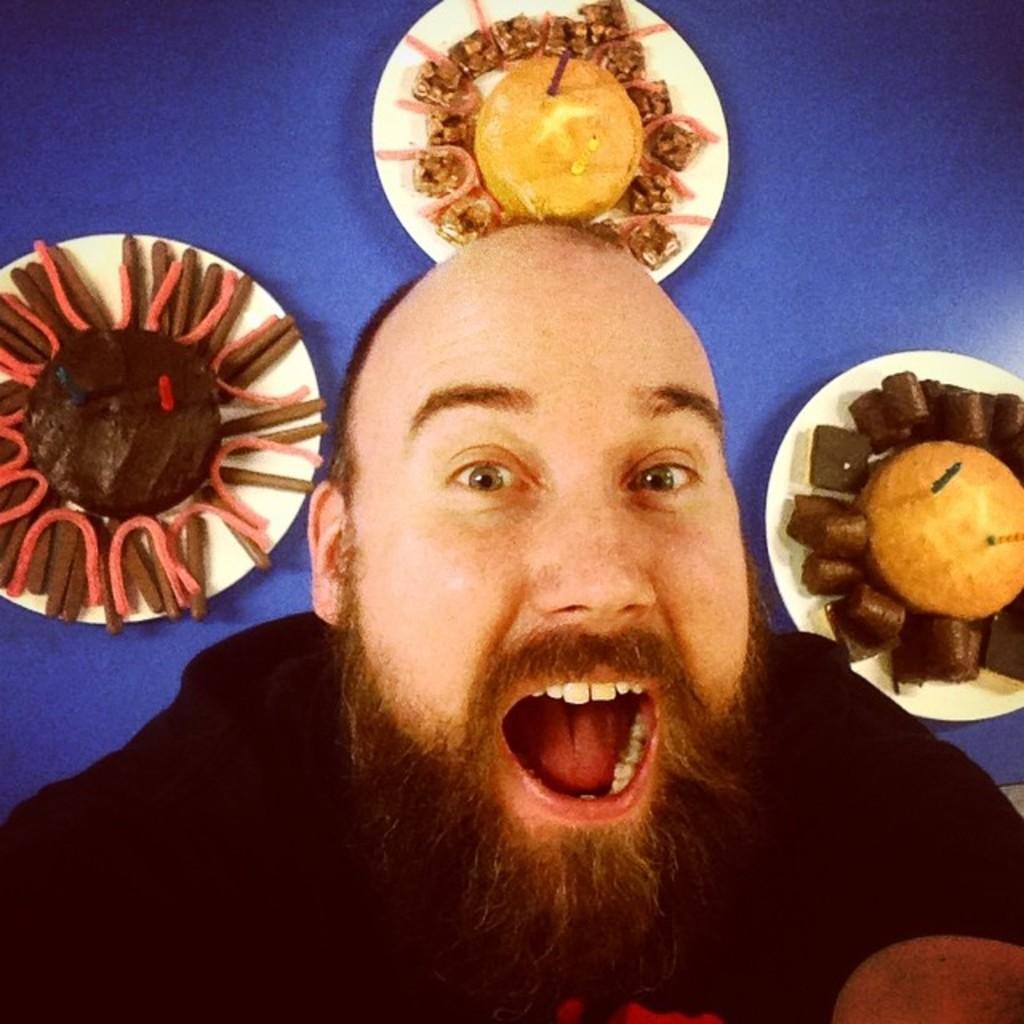Can you describe this image briefly? Here I can see a man opened his mouth and giving pose for the picture. In the background there are three plants which consists of different food items and these three plates are placed on a table which is in blue color. 